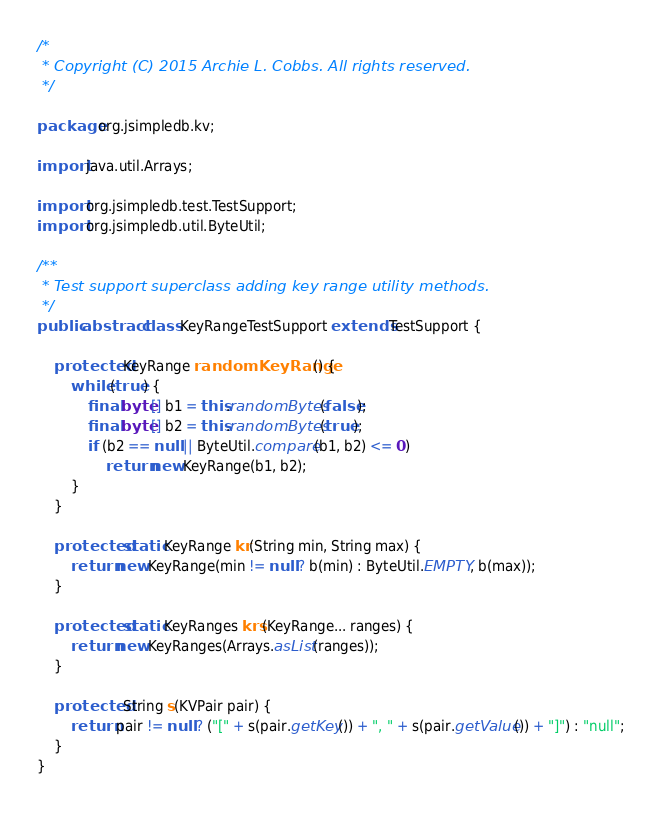<code> <loc_0><loc_0><loc_500><loc_500><_Java_>
/*
 * Copyright (C) 2015 Archie L. Cobbs. All rights reserved.
 */

package org.jsimpledb.kv;

import java.util.Arrays;

import org.jsimpledb.test.TestSupport;
import org.jsimpledb.util.ByteUtil;

/**
 * Test support superclass adding key range utility methods.
 */
public abstract class KeyRangeTestSupport extends TestSupport {

    protected KeyRange randomKeyRange() {
        while (true) {
            final byte[] b1 = this.randomBytes(false);
            final byte[] b2 = this.randomBytes(true);
            if (b2 == null || ByteUtil.compare(b1, b2) <= 0)
                return new KeyRange(b1, b2);
        }
    }

    protected static KeyRange kr(String min, String max) {
        return new KeyRange(min != null ? b(min) : ByteUtil.EMPTY, b(max));
    }

    protected static KeyRanges krs(KeyRange... ranges) {
        return new KeyRanges(Arrays.asList(ranges));
    }

    protected String s(KVPair pair) {
        return pair != null ? ("[" + s(pair.getKey()) + ", " + s(pair.getValue()) + "]") : "null";
    }
}
</code> 